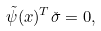Convert formula to latex. <formula><loc_0><loc_0><loc_500><loc_500>\tilde { \psi } ( x ) ^ { T } \check { \sigma } = 0 ,</formula> 